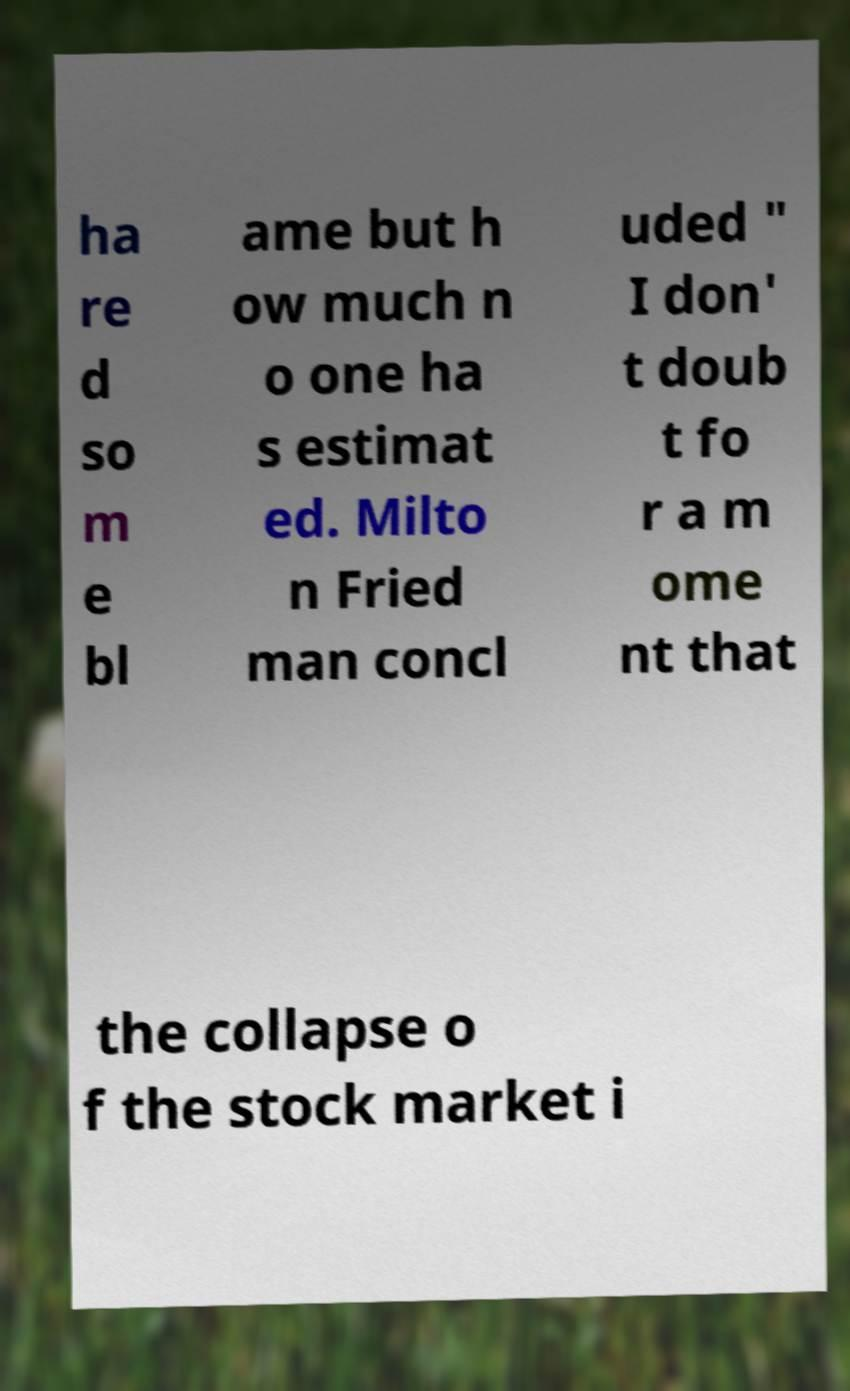Could you extract and type out the text from this image? ha re d so m e bl ame but h ow much n o one ha s estimat ed. Milto n Fried man concl uded " I don' t doub t fo r a m ome nt that the collapse o f the stock market i 